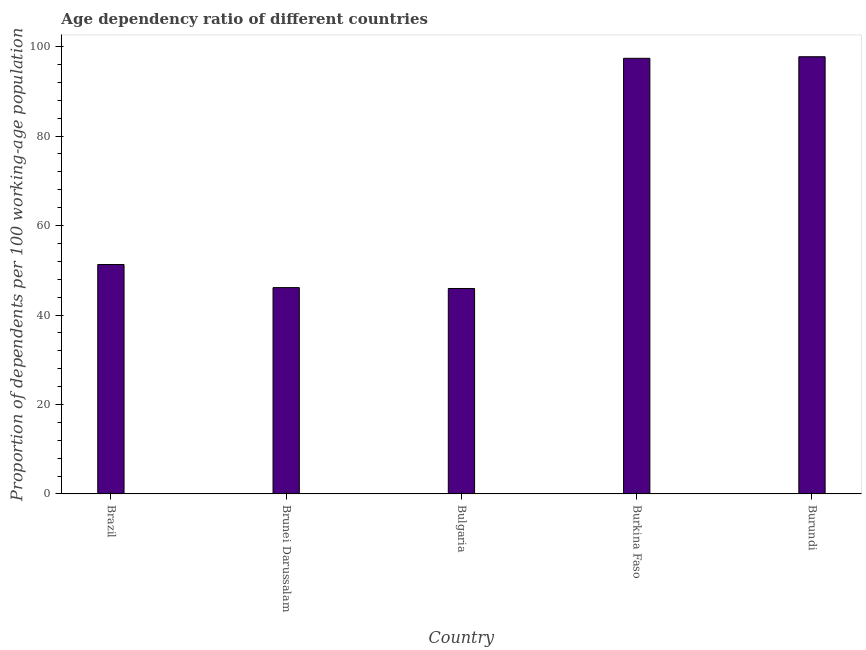Does the graph contain grids?
Your response must be concise. No. What is the title of the graph?
Offer a very short reply. Age dependency ratio of different countries. What is the label or title of the X-axis?
Offer a very short reply. Country. What is the label or title of the Y-axis?
Give a very brief answer. Proportion of dependents per 100 working-age population. What is the age dependency ratio in Burkina Faso?
Your response must be concise. 97.38. Across all countries, what is the maximum age dependency ratio?
Your response must be concise. 97.73. Across all countries, what is the minimum age dependency ratio?
Your answer should be very brief. 45.93. In which country was the age dependency ratio maximum?
Provide a short and direct response. Burundi. What is the sum of the age dependency ratio?
Offer a terse response. 338.44. What is the difference between the age dependency ratio in Bulgaria and Burkina Faso?
Your answer should be very brief. -51.45. What is the average age dependency ratio per country?
Offer a terse response. 67.69. What is the median age dependency ratio?
Ensure brevity in your answer.  51.29. What is the ratio of the age dependency ratio in Burkina Faso to that in Burundi?
Offer a very short reply. 1. Is the age dependency ratio in Brunei Darussalam less than that in Burkina Faso?
Your response must be concise. Yes. What is the difference between the highest and the second highest age dependency ratio?
Your answer should be compact. 0.35. What is the difference between the highest and the lowest age dependency ratio?
Make the answer very short. 51.8. How many bars are there?
Keep it short and to the point. 5. What is the difference between two consecutive major ticks on the Y-axis?
Make the answer very short. 20. What is the Proportion of dependents per 100 working-age population in Brazil?
Give a very brief answer. 51.29. What is the Proportion of dependents per 100 working-age population of Brunei Darussalam?
Ensure brevity in your answer.  46.12. What is the Proportion of dependents per 100 working-age population of Bulgaria?
Provide a short and direct response. 45.93. What is the Proportion of dependents per 100 working-age population in Burkina Faso?
Your answer should be compact. 97.38. What is the Proportion of dependents per 100 working-age population in Burundi?
Ensure brevity in your answer.  97.73. What is the difference between the Proportion of dependents per 100 working-age population in Brazil and Brunei Darussalam?
Provide a short and direct response. 5.16. What is the difference between the Proportion of dependents per 100 working-age population in Brazil and Bulgaria?
Keep it short and to the point. 5.36. What is the difference between the Proportion of dependents per 100 working-age population in Brazil and Burkina Faso?
Make the answer very short. -46.09. What is the difference between the Proportion of dependents per 100 working-age population in Brazil and Burundi?
Provide a succinct answer. -46.44. What is the difference between the Proportion of dependents per 100 working-age population in Brunei Darussalam and Bulgaria?
Make the answer very short. 0.2. What is the difference between the Proportion of dependents per 100 working-age population in Brunei Darussalam and Burkina Faso?
Keep it short and to the point. -51.25. What is the difference between the Proportion of dependents per 100 working-age population in Brunei Darussalam and Burundi?
Your answer should be compact. -51.61. What is the difference between the Proportion of dependents per 100 working-age population in Bulgaria and Burkina Faso?
Provide a succinct answer. -51.45. What is the difference between the Proportion of dependents per 100 working-age population in Bulgaria and Burundi?
Provide a short and direct response. -51.8. What is the difference between the Proportion of dependents per 100 working-age population in Burkina Faso and Burundi?
Ensure brevity in your answer.  -0.35. What is the ratio of the Proportion of dependents per 100 working-age population in Brazil to that in Brunei Darussalam?
Keep it short and to the point. 1.11. What is the ratio of the Proportion of dependents per 100 working-age population in Brazil to that in Bulgaria?
Your response must be concise. 1.12. What is the ratio of the Proportion of dependents per 100 working-age population in Brazil to that in Burkina Faso?
Give a very brief answer. 0.53. What is the ratio of the Proportion of dependents per 100 working-age population in Brazil to that in Burundi?
Provide a short and direct response. 0.53. What is the ratio of the Proportion of dependents per 100 working-age population in Brunei Darussalam to that in Burkina Faso?
Make the answer very short. 0.47. What is the ratio of the Proportion of dependents per 100 working-age population in Brunei Darussalam to that in Burundi?
Offer a very short reply. 0.47. What is the ratio of the Proportion of dependents per 100 working-age population in Bulgaria to that in Burkina Faso?
Ensure brevity in your answer.  0.47. What is the ratio of the Proportion of dependents per 100 working-age population in Bulgaria to that in Burundi?
Keep it short and to the point. 0.47. 